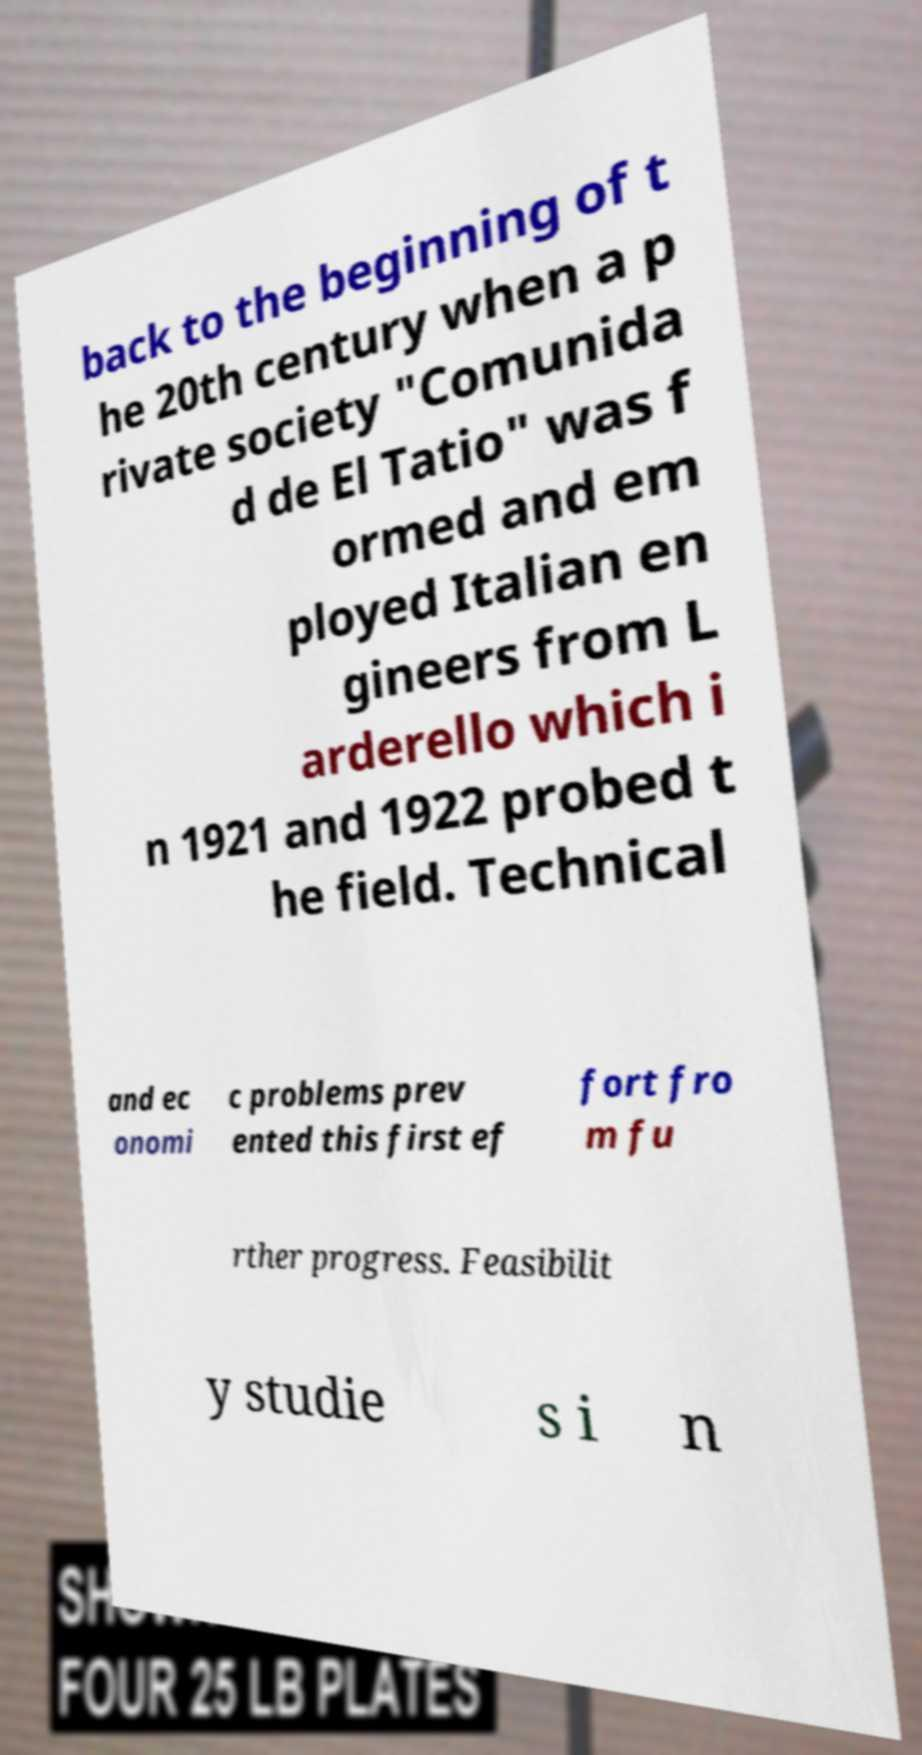Please identify and transcribe the text found in this image. back to the beginning of t he 20th century when a p rivate society "Comunida d de El Tatio" was f ormed and em ployed Italian en gineers from L arderello which i n 1921 and 1922 probed t he field. Technical and ec onomi c problems prev ented this first ef fort fro m fu rther progress. Feasibilit y studie s i n 